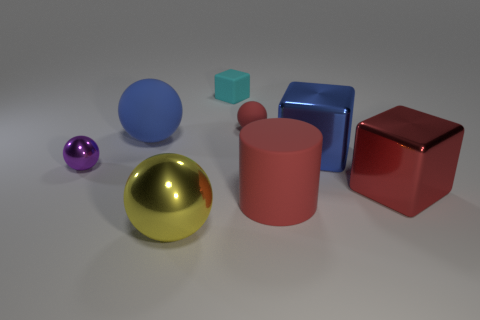Subtract 1 spheres. How many spheres are left? 3 Subtract all red spheres. How many spheres are left? 3 Subtract all tiny rubber spheres. How many spheres are left? 3 Add 1 red shiny things. How many objects exist? 9 Subtract all brown balls. Subtract all purple cubes. How many balls are left? 4 Subtract all cylinders. How many objects are left? 7 Subtract all tiny green rubber balls. Subtract all large red shiny blocks. How many objects are left? 7 Add 1 tiny red rubber balls. How many tiny red rubber balls are left? 2 Add 7 tiny balls. How many tiny balls exist? 9 Subtract 0 cyan balls. How many objects are left? 8 